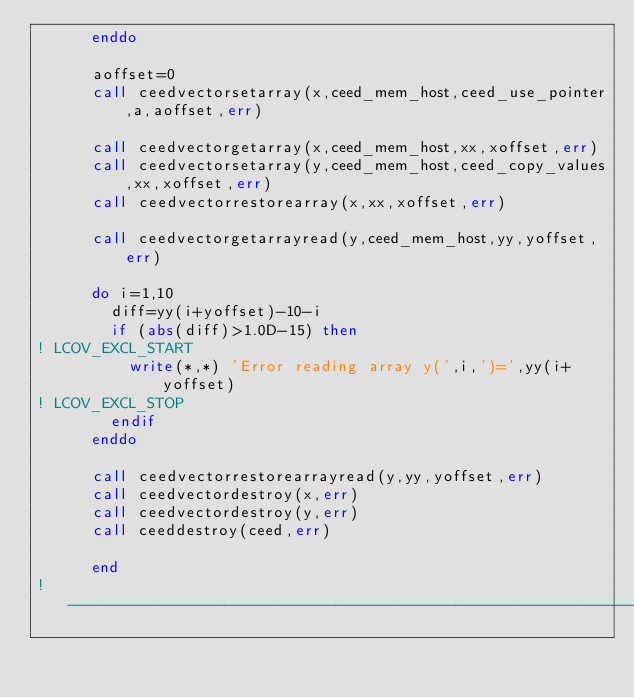Convert code to text. <code><loc_0><loc_0><loc_500><loc_500><_FORTRAN_>      enddo

      aoffset=0
      call ceedvectorsetarray(x,ceed_mem_host,ceed_use_pointer,a,aoffset,err)

      call ceedvectorgetarray(x,ceed_mem_host,xx,xoffset,err)
      call ceedvectorsetarray(y,ceed_mem_host,ceed_copy_values,xx,xoffset,err)
      call ceedvectorrestorearray(x,xx,xoffset,err)

      call ceedvectorgetarrayread(y,ceed_mem_host,yy,yoffset,err)

      do i=1,10
        diff=yy(i+yoffset)-10-i
        if (abs(diff)>1.0D-15) then
! LCOV_EXCL_START
          write(*,*) 'Error reading array y(',i,')=',yy(i+yoffset)
! LCOV_EXCL_STOP
        endif
      enddo

      call ceedvectorrestorearrayread(y,yy,yoffset,err)
      call ceedvectordestroy(x,err)
      call ceedvectordestroy(y,err)
      call ceeddestroy(ceed,err)

      end
!-----------------------------------------------------------------------
</code> 